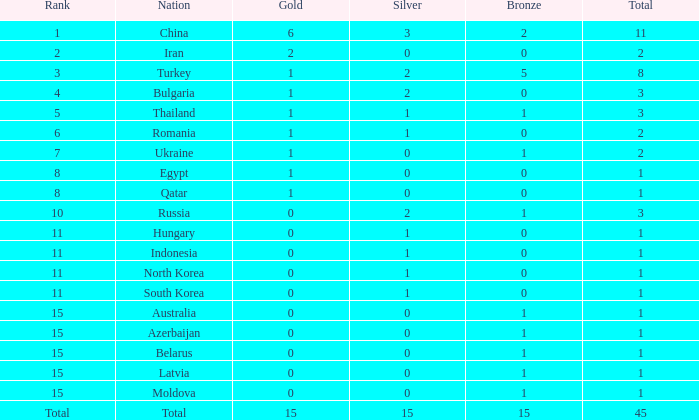What is the total number of bronze medals for the country with fewer than 1 silver medal? None. 